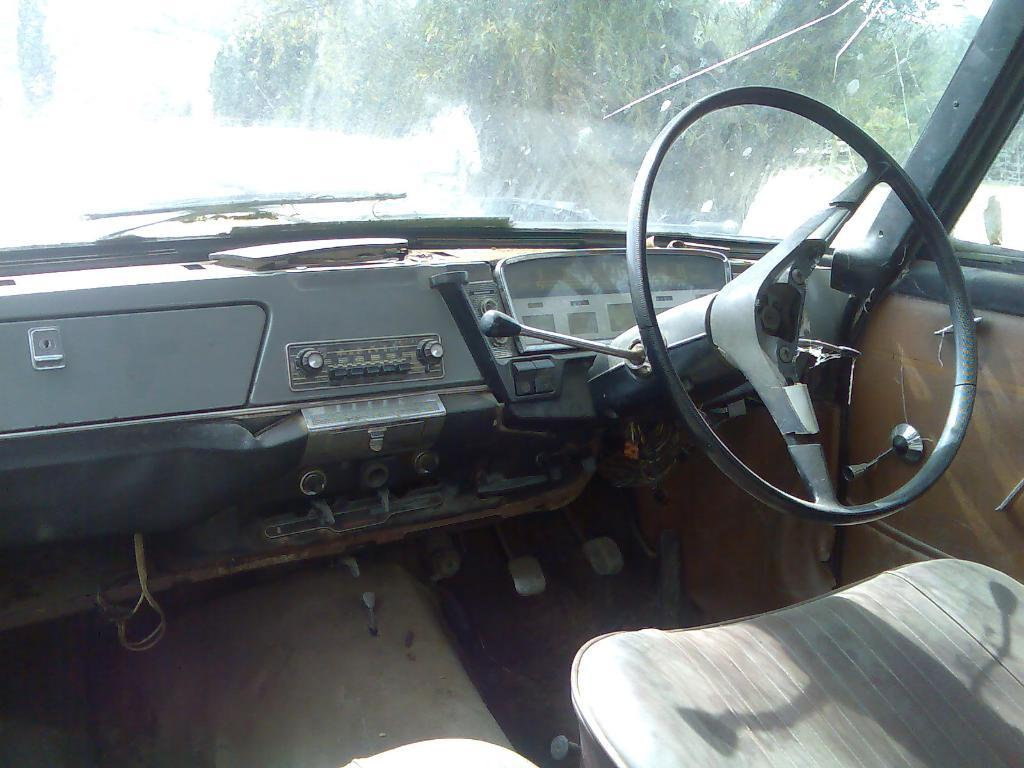What is the setting of the image? The image shows the inside view of a vehicle. What can be seen outside the vehicle in the image? There are trees visible in the background of the image. How does the vehicle burn fuel while driving in the image? The image does not show the vehicle in motion or provide any information about how it burns fuel. 